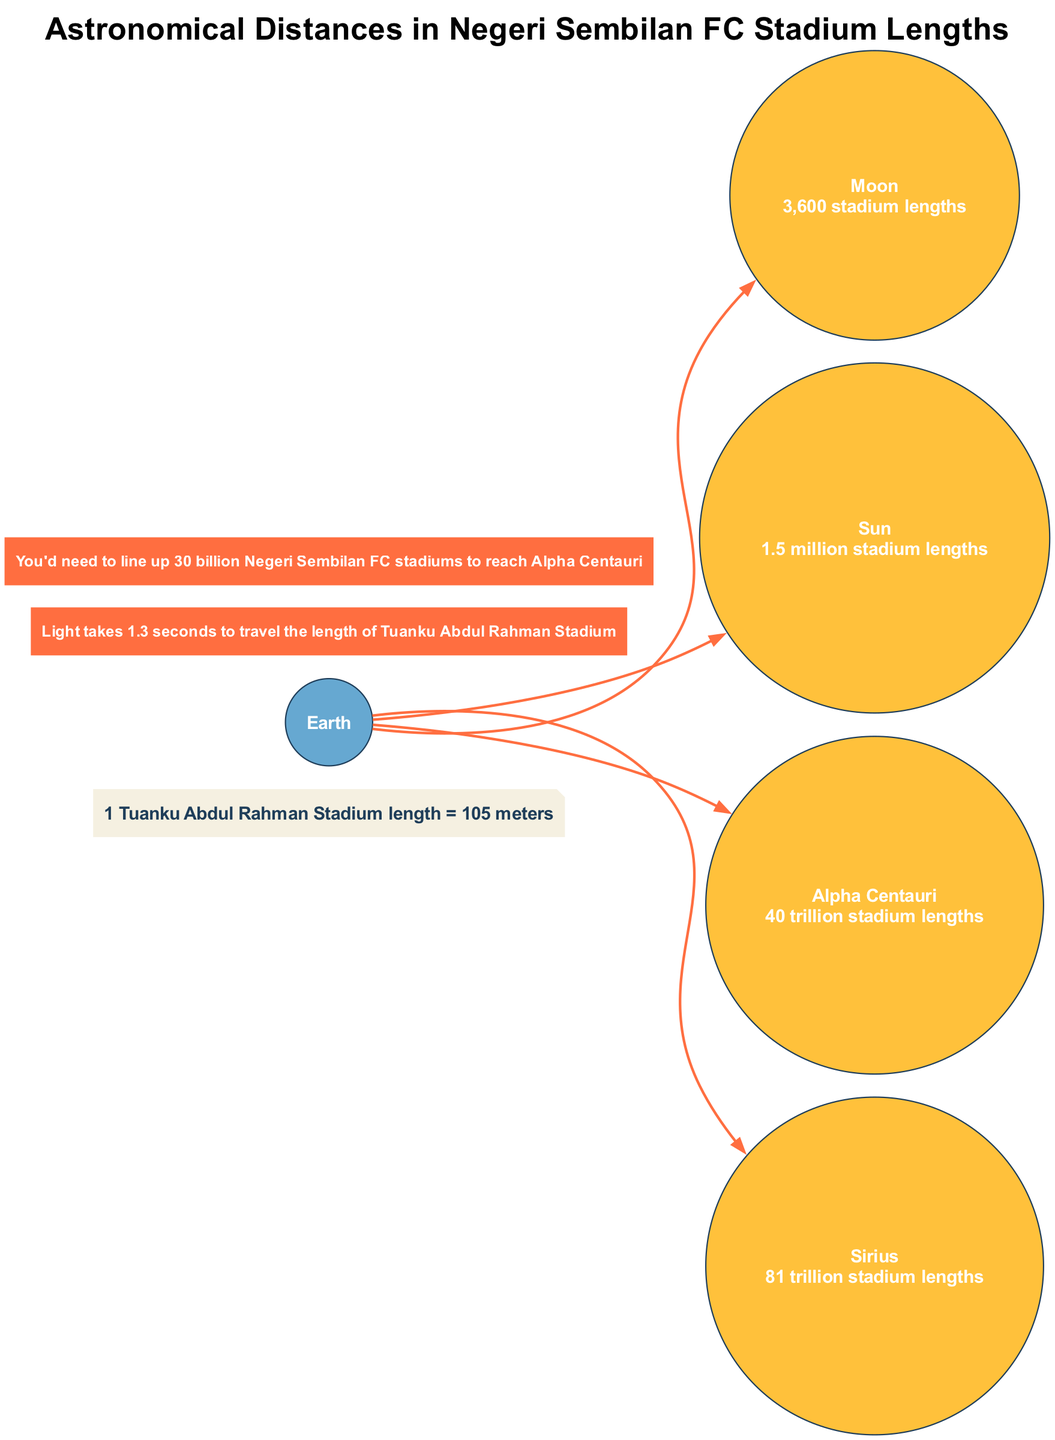What is the distance to the Moon in stadium lengths? The diagram indicates that the distance to the Moon is represented as 3,600 stadium lengths. This is directly stated next to the Moon node in the diagram.
Answer: 3,600 stadium lengths What celestial object is 1.5 million stadium lengths away? The diagram shows that the Sun is positioned at a distance of 1.5 million stadium lengths, which can be identified by examining the details next to the Sun node.
Answer: Sun How many times does the distance to Sirius exceed the distance to the Moon? The distance to Sirius is 81 trillion stadium lengths, while the distance to the Moon is 3,600 stadium lengths. To find out how many times Sirius’ distance exceeds that of the Moon, divide 81 trillion by 3,600, which results in approximately 22.5 billion times.
Answer: 22.5 billion Which celestial object has the shortest distance from Earth? The diagram illustrates that the Moon is the closest celestial object with a distance of 3,600 stadium lengths, making it the one closest to Earth as per the diagram.
Answer: Moon What fun fact is related to the light travel time across the stadium? One of the fun facts in the diagram states that light takes 1.3 seconds to travel the length of Tuanku Abdul Rahman Stadium, which is explicitly written under the fun facts section.
Answer: 1.3 seconds 